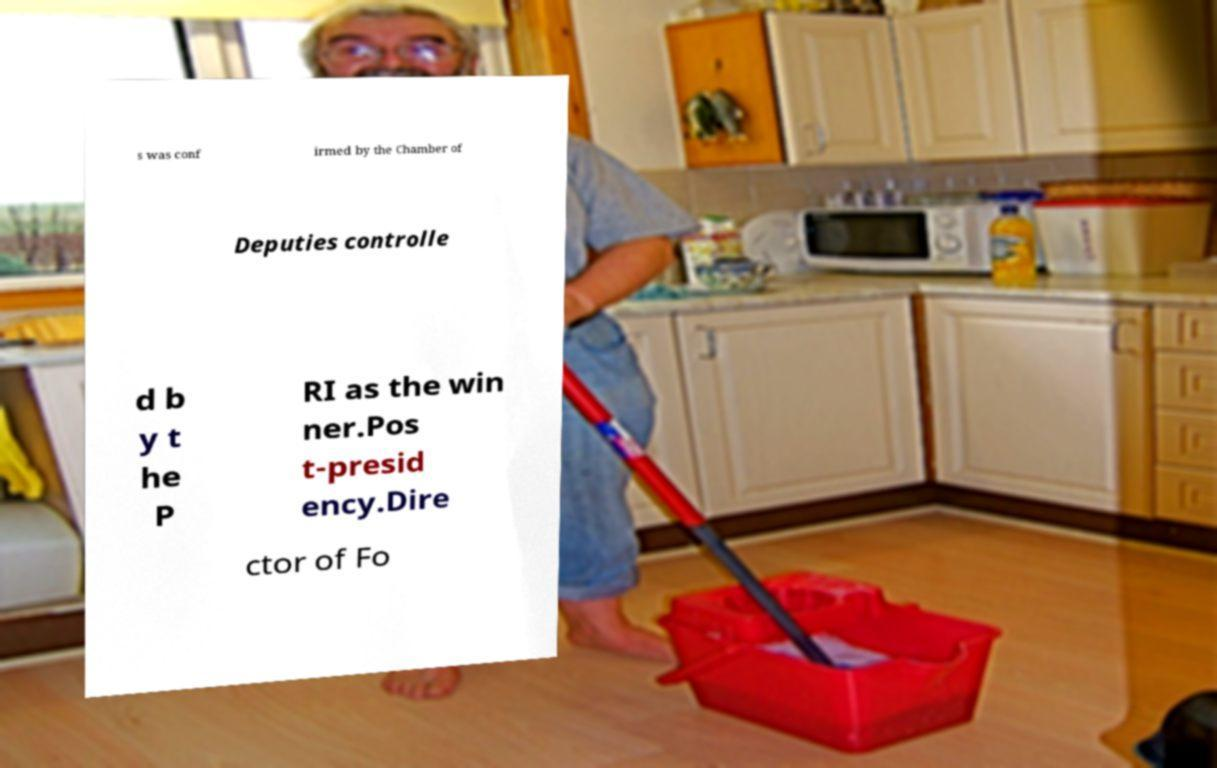Can you read and provide the text displayed in the image?This photo seems to have some interesting text. Can you extract and type it out for me? s was conf irmed by the Chamber of Deputies controlle d b y t he P RI as the win ner.Pos t-presid ency.Dire ctor of Fo 